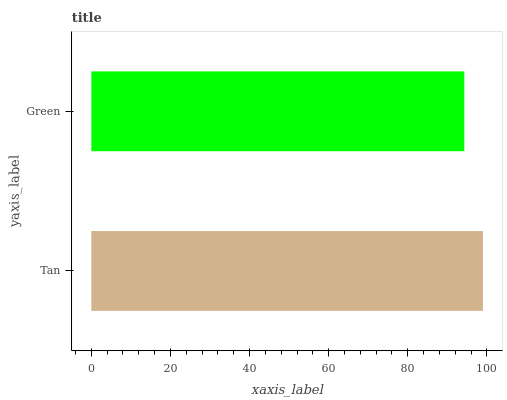Is Green the minimum?
Answer yes or no. Yes. Is Tan the maximum?
Answer yes or no. Yes. Is Green the maximum?
Answer yes or no. No. Is Tan greater than Green?
Answer yes or no. Yes. Is Green less than Tan?
Answer yes or no. Yes. Is Green greater than Tan?
Answer yes or no. No. Is Tan less than Green?
Answer yes or no. No. Is Tan the high median?
Answer yes or no. Yes. Is Green the low median?
Answer yes or no. Yes. Is Green the high median?
Answer yes or no. No. Is Tan the low median?
Answer yes or no. No. 